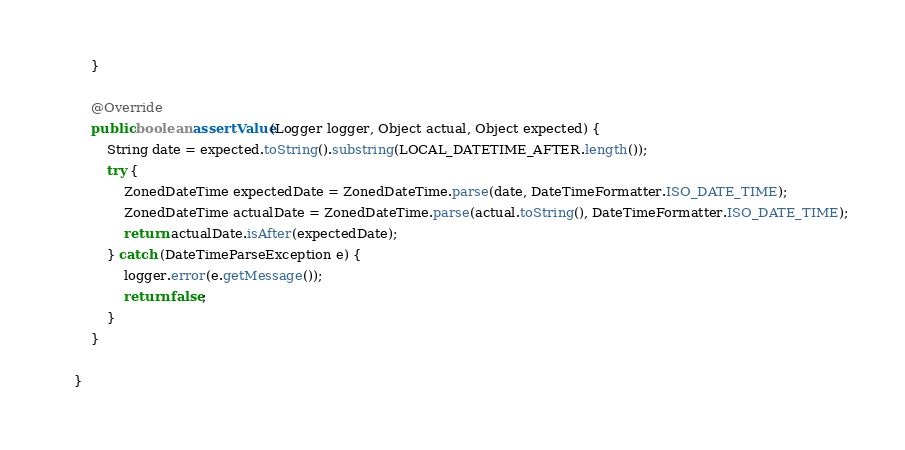Convert code to text. <code><loc_0><loc_0><loc_500><loc_500><_Java_>    }

    @Override
    public boolean assertValue(Logger logger, Object actual, Object expected) {
        String date = expected.toString().substring(LOCAL_DATETIME_AFTER.length());
        try {
            ZonedDateTime expectedDate = ZonedDateTime.parse(date, DateTimeFormatter.ISO_DATE_TIME);
            ZonedDateTime actualDate = ZonedDateTime.parse(actual.toString(), DateTimeFormatter.ISO_DATE_TIME);
            return actualDate.isAfter(expectedDate);
        } catch (DateTimeParseException e) {
            logger.error(e.getMessage());
            return false;
        }
    }

}
</code> 